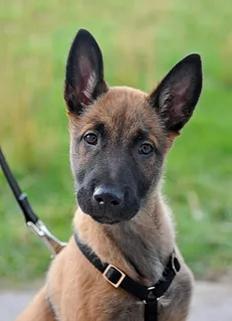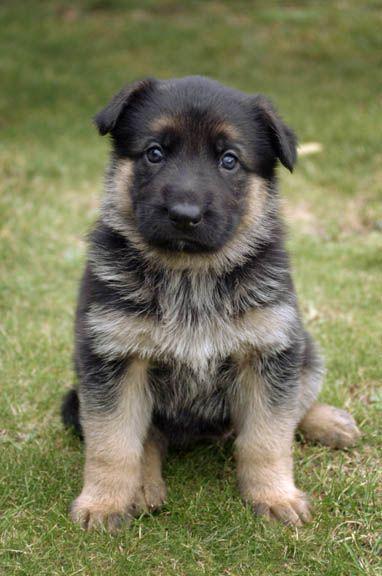The first image is the image on the left, the second image is the image on the right. Given the left and right images, does the statement "One of the dogs is on a leash." hold true? Answer yes or no. Yes. 